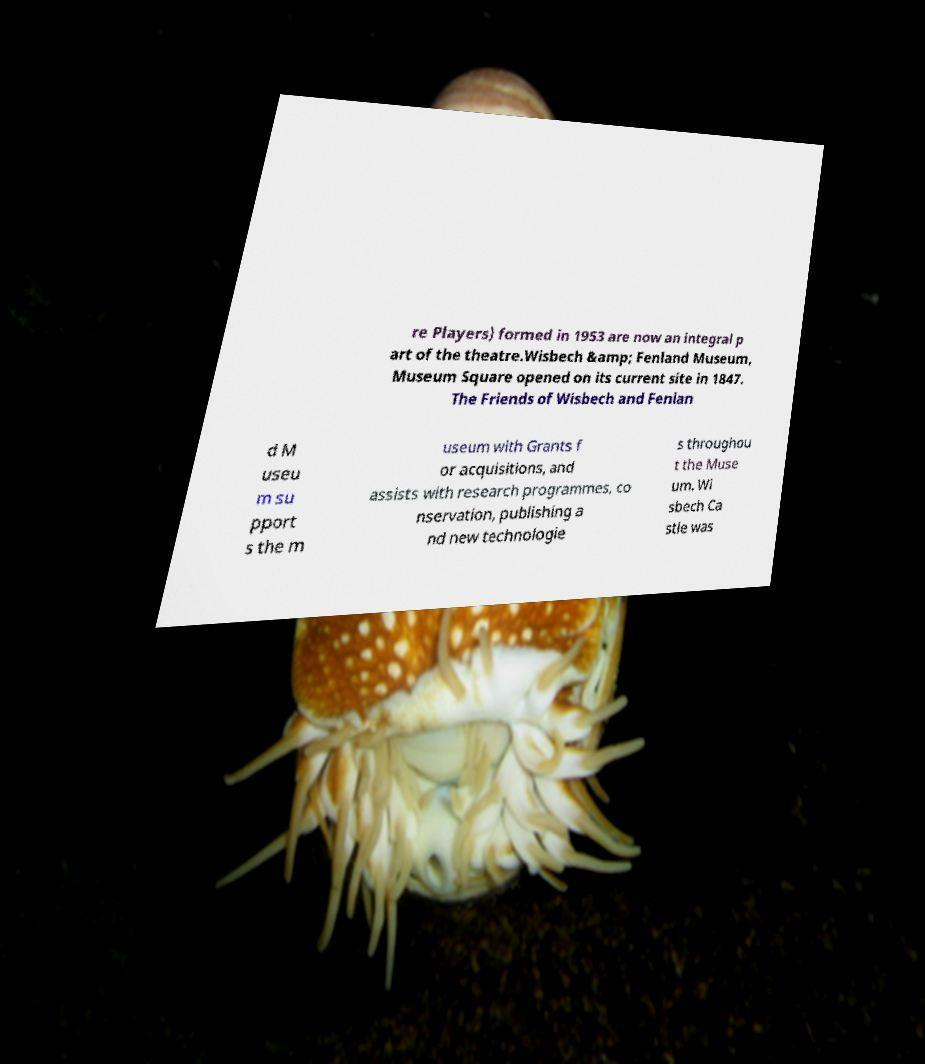What messages or text are displayed in this image? I need them in a readable, typed format. re Players) formed in 1953 are now an integral p art of the theatre.Wisbech &amp; Fenland Museum, Museum Square opened on its current site in 1847. The Friends of Wisbech and Fenlan d M useu m su pport s the m useum with Grants f or acquisitions, and assists with research programmes, co nservation, publishing a nd new technologie s throughou t the Muse um. Wi sbech Ca stle was 